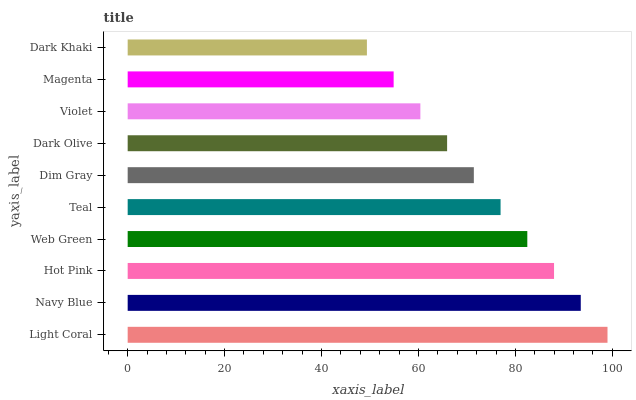Is Dark Khaki the minimum?
Answer yes or no. Yes. Is Light Coral the maximum?
Answer yes or no. Yes. Is Navy Blue the minimum?
Answer yes or no. No. Is Navy Blue the maximum?
Answer yes or no. No. Is Light Coral greater than Navy Blue?
Answer yes or no. Yes. Is Navy Blue less than Light Coral?
Answer yes or no. Yes. Is Navy Blue greater than Light Coral?
Answer yes or no. No. Is Light Coral less than Navy Blue?
Answer yes or no. No. Is Teal the high median?
Answer yes or no. Yes. Is Dim Gray the low median?
Answer yes or no. Yes. Is Web Green the high median?
Answer yes or no. No. Is Magenta the low median?
Answer yes or no. No. 